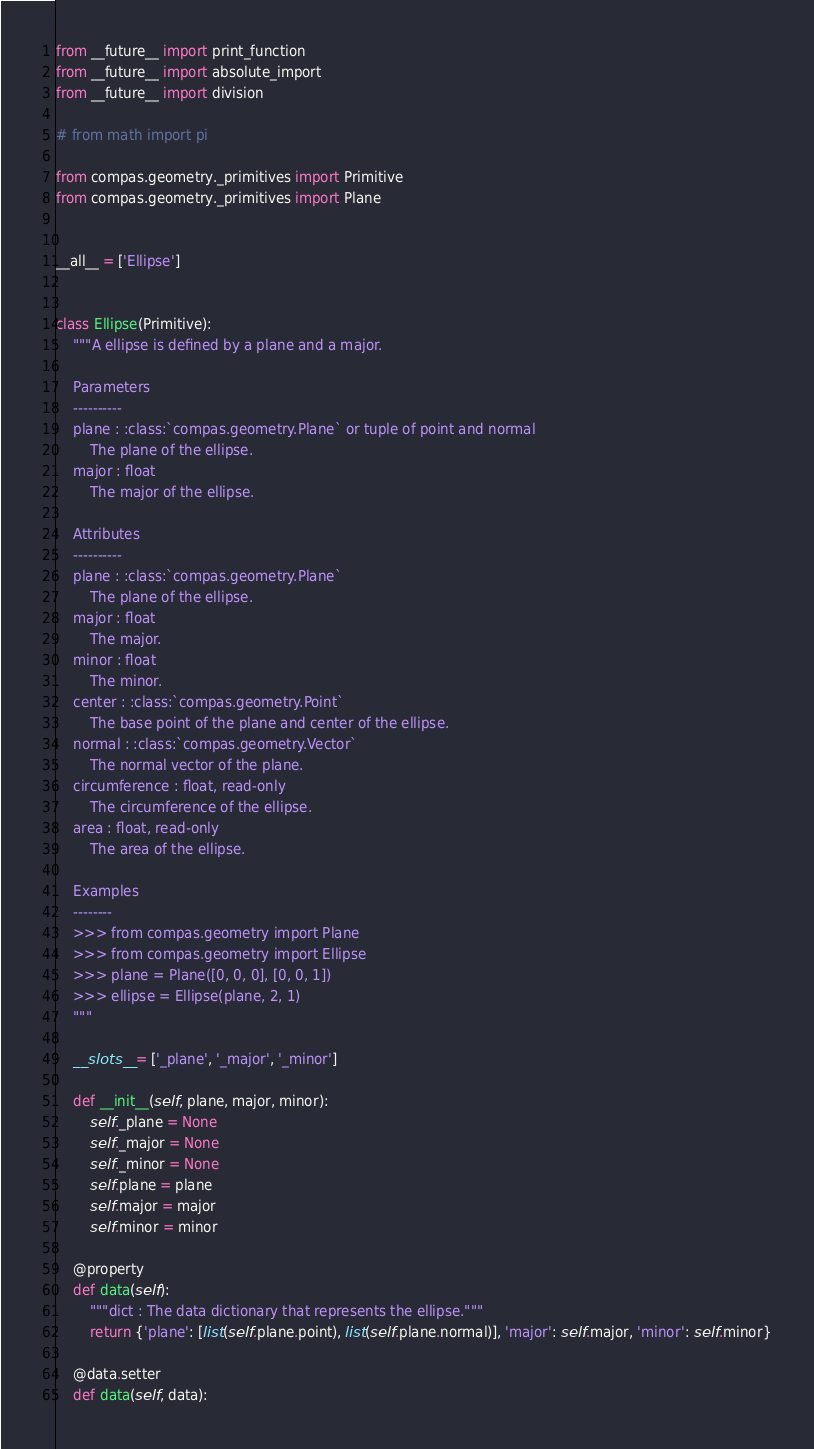Convert code to text. <code><loc_0><loc_0><loc_500><loc_500><_Python_>from __future__ import print_function
from __future__ import absolute_import
from __future__ import division

# from math import pi

from compas.geometry._primitives import Primitive
from compas.geometry._primitives import Plane


__all__ = ['Ellipse']


class Ellipse(Primitive):
    """A ellipse is defined by a plane and a major.

    Parameters
    ----------
    plane : :class:`compas.geometry.Plane` or tuple of point and normal
        The plane of the ellipse.
    major : float
        The major of the ellipse.

    Attributes
    ----------
    plane : :class:`compas.geometry.Plane`
        The plane of the ellipse.
    major : float
        The major.
    minor : float
        The minor.
    center : :class:`compas.geometry.Point`
        The base point of the plane and center of the ellipse.
    normal : :class:`compas.geometry.Vector`
        The normal vector of the plane.
    circumference : float, read-only
        The circumference of the ellipse.
    area : float, read-only
        The area of the ellipse.

    Examples
    --------
    >>> from compas.geometry import Plane
    >>> from compas.geometry import Ellipse
    >>> plane = Plane([0, 0, 0], [0, 0, 1])
    >>> ellipse = Ellipse(plane, 2, 1)
    """

    __slots__ = ['_plane', '_major', '_minor']

    def __init__(self, plane, major, minor):
        self._plane = None
        self._major = None
        self._minor = None
        self.plane = plane
        self.major = major
        self.minor = minor

    @property
    def data(self):
        """dict : The data dictionary that represents the ellipse."""
        return {'plane': [list(self.plane.point), list(self.plane.normal)], 'major': self.major, 'minor': self.minor}

    @data.setter
    def data(self, data):</code> 